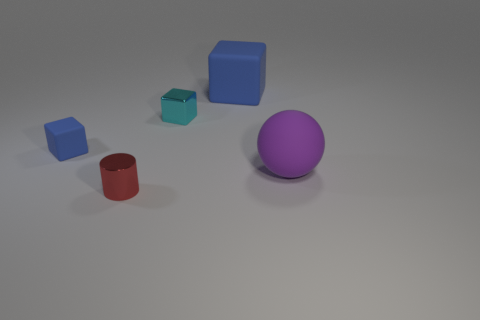How many purple matte objects are the same shape as the small cyan thing?
Your answer should be very brief. 0. There is a small cube behind the matte object to the left of the large thing that is on the left side of the matte sphere; what is its color?
Offer a terse response. Cyan. Are the blue block that is on the right side of the metal cube and the cube on the left side of the tiny cyan metallic cube made of the same material?
Your answer should be compact. Yes. How many things are either blocks that are to the right of the shiny block or big green shiny cubes?
Offer a very short reply. 1. How many things are large brown metallic cylinders or things that are behind the rubber sphere?
Offer a very short reply. 3. What number of other red things have the same size as the red metallic thing?
Make the answer very short. 0. Are there fewer small red metal cylinders on the right side of the large blue rubber block than tiny objects in front of the tiny rubber object?
Keep it short and to the point. Yes. What number of matte objects are tiny red objects or large green cylinders?
Provide a succinct answer. 0. The tiny cyan thing is what shape?
Ensure brevity in your answer.  Cube. There is a blue object that is the same size as the metal cube; what material is it?
Offer a terse response. Rubber. 